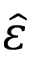Convert formula to latex. <formula><loc_0><loc_0><loc_500><loc_500>\hat { \varepsilon }</formula> 